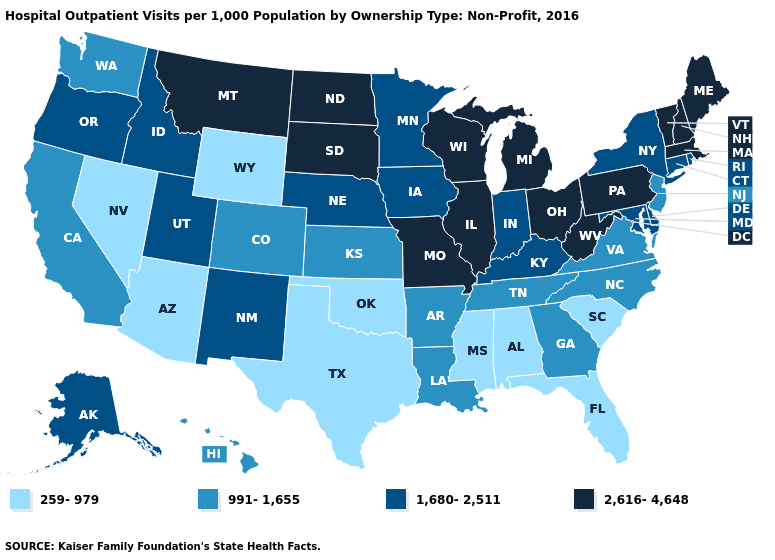Does the map have missing data?
Quick response, please. No. What is the value of Rhode Island?
Keep it brief. 1,680-2,511. How many symbols are there in the legend?
Be succinct. 4. What is the lowest value in the Northeast?
Short answer required. 991-1,655. Does Missouri have the highest value in the MidWest?
Quick response, please. Yes. Does North Dakota have the same value as Michigan?
Be succinct. Yes. What is the value of Indiana?
Give a very brief answer. 1,680-2,511. Name the states that have a value in the range 991-1,655?
Quick response, please. Arkansas, California, Colorado, Georgia, Hawaii, Kansas, Louisiana, New Jersey, North Carolina, Tennessee, Virginia, Washington. Which states hav the highest value in the South?
Give a very brief answer. West Virginia. Does Tennessee have a higher value than Idaho?
Concise answer only. No. What is the value of Illinois?
Concise answer only. 2,616-4,648. Which states have the highest value in the USA?
Give a very brief answer. Illinois, Maine, Massachusetts, Michigan, Missouri, Montana, New Hampshire, North Dakota, Ohio, Pennsylvania, South Dakota, Vermont, West Virginia, Wisconsin. Does the first symbol in the legend represent the smallest category?
Quick response, please. Yes. What is the value of Wyoming?
Quick response, please. 259-979. Which states have the lowest value in the MidWest?
Short answer required. Kansas. 